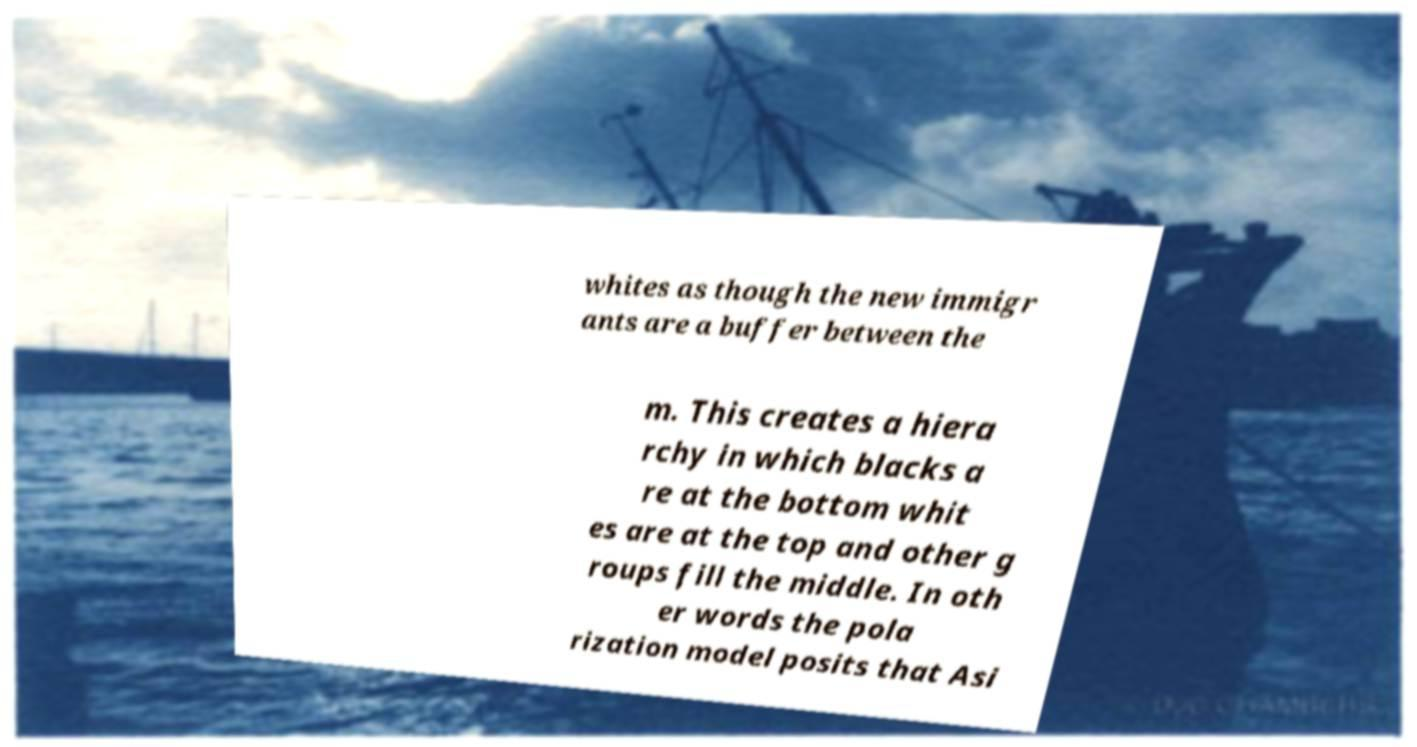Could you assist in decoding the text presented in this image and type it out clearly? whites as though the new immigr ants are a buffer between the m. This creates a hiera rchy in which blacks a re at the bottom whit es are at the top and other g roups fill the middle. In oth er words the pola rization model posits that Asi 